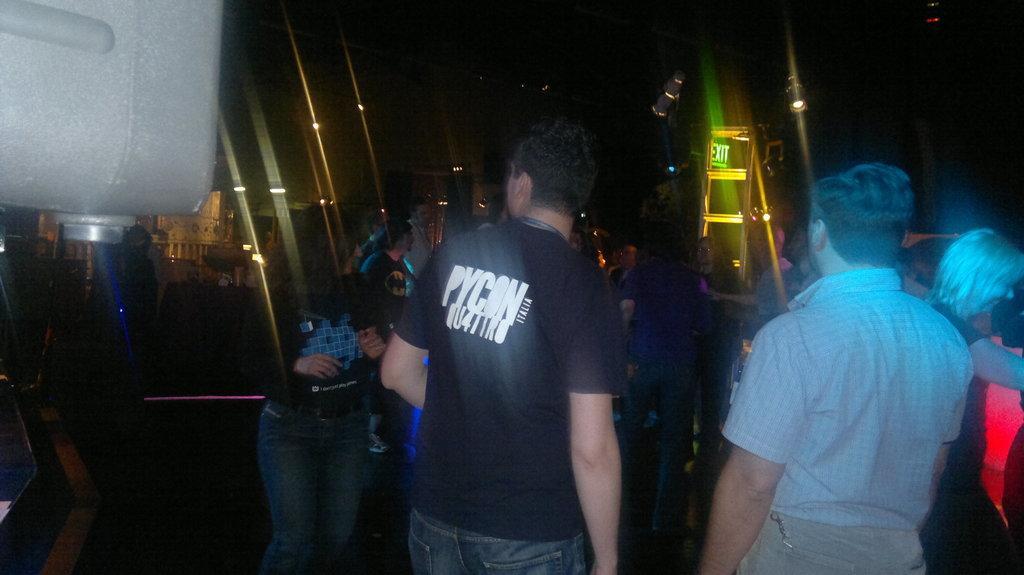Describe this image in one or two sentences. In the foreground of the picture there are people dancing. In the background there are lights and buildings. At the top it is dark. 